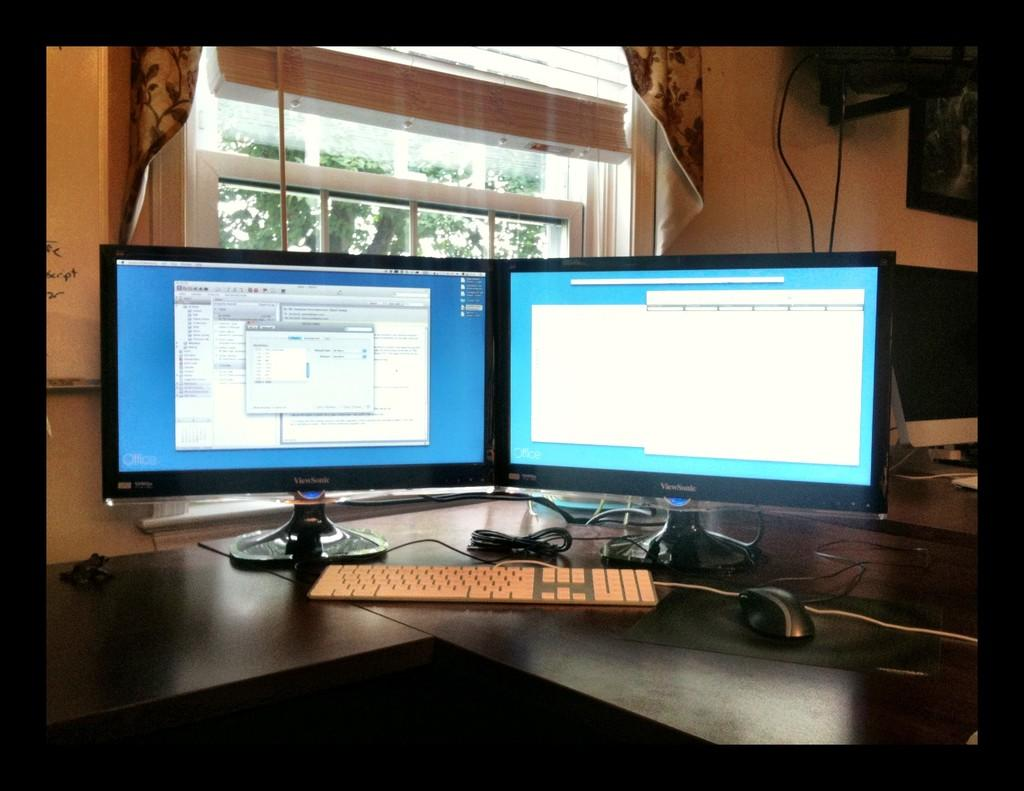<image>
Summarize the visual content of the image. Two monitors on a wooden desk with the brand name ViewSonic on them 